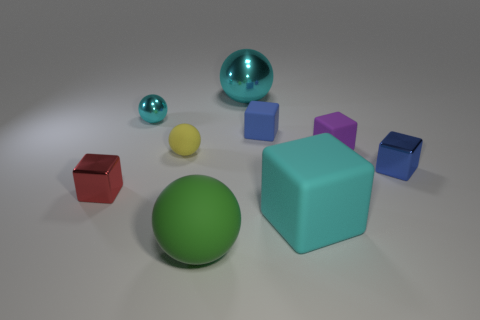Can you describe the colors of the objects? Certainly! In the image, there is a diverse palette of colors. You can see a green sphere, red and blue cubes, as well as smaller spheres in cyan and a reflective turquoise. The combination of these colors presents a visual variety. Which object stands out the most to you? The cyan sphere stands out prominently due to its larger size and central position, which naturally draws the viewer's gaze amidst the collection of geometric shapes. 